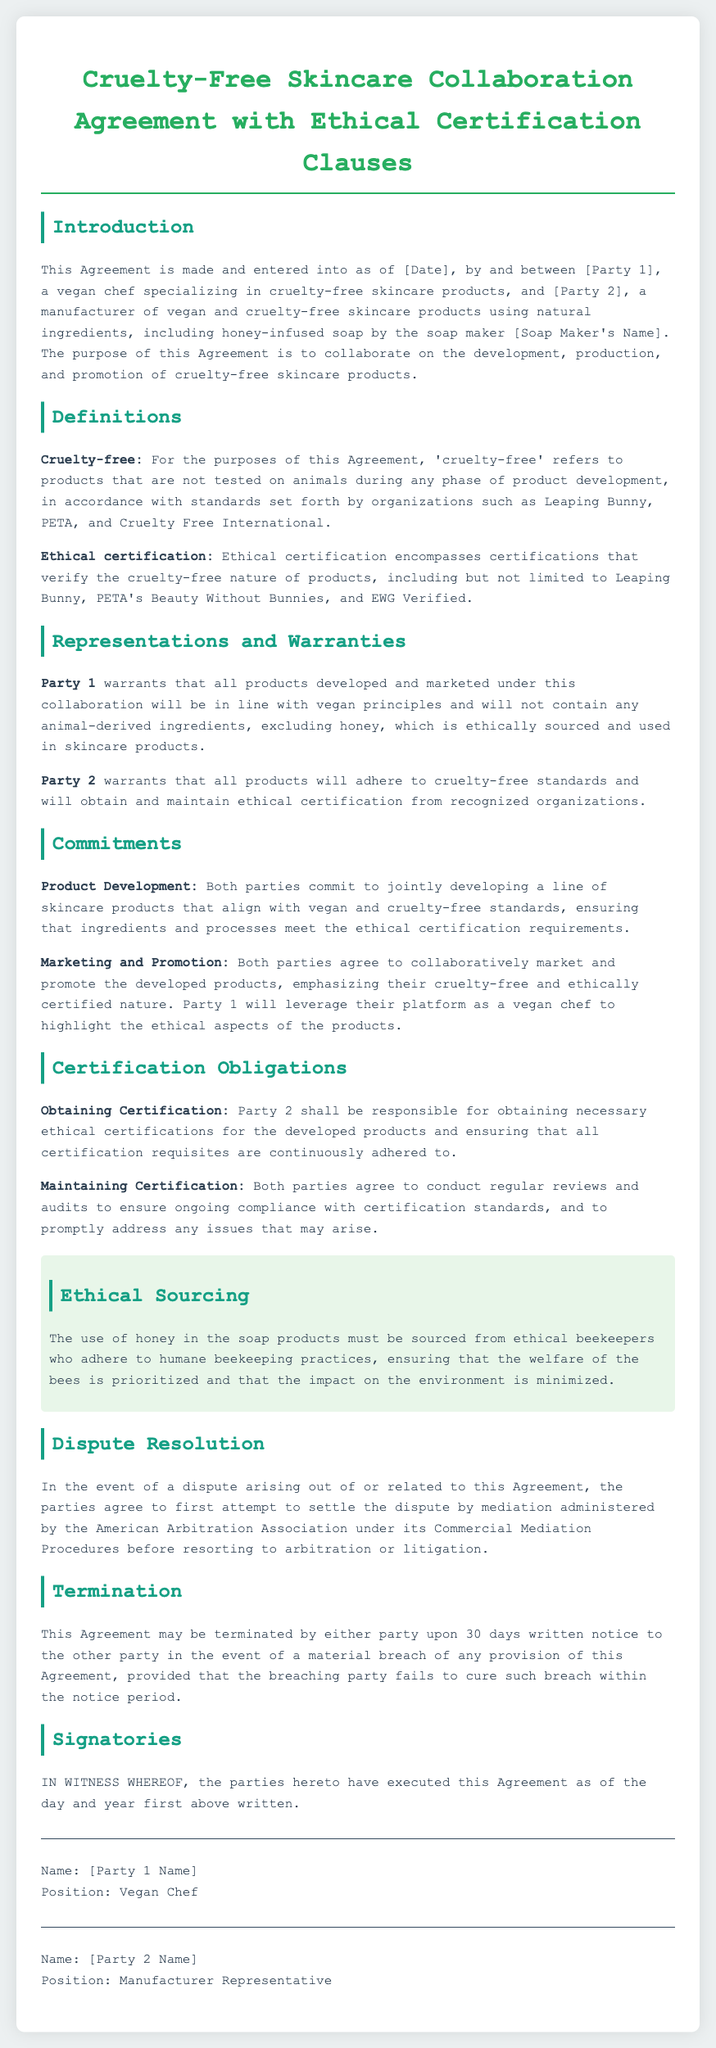What is the title of the document? The title of the document is provided at the top of the agreement section.
Answer: Cruelty-Free Skincare Collaboration Agreement with Ethical Certification Clauses Who are the parties involved in the Agreement? The parties are specified in the introduction of the document.
Answer: [Party 1] and [Party 2] What is the warranty from Party 1 regarding product ingredients? The document specifies what Party 1 guarantees about the products in the Representations and Warranties section.
Answer: Will not contain any animal-derived ingredients, excluding honey Which certification organizations are mentioned? The types of organizations that provide certification are listed in the Definitions section.
Answer: Leaping Bunny, PETA, Cruelty Free International What is Party 2's responsibility regarding certification? The obligations of Party 2 concerning certification can be found under Certification Obligations.
Answer: Obtaining necessary ethical certifications What must be prioritized concerning honey sourcing? The document outlines crucial aspects of honey sourcing in the Ethical Sourcing section.
Answer: Welfare of the bees Which method is suggested for resolving disputes? The preferred method for resolving conflicts is detailed in the Dispute Resolution section.
Answer: Mediation What is the notice period for termination of the Agreement? The notice period for termination is specified in the Termination section of the document.
Answer: 30 days 